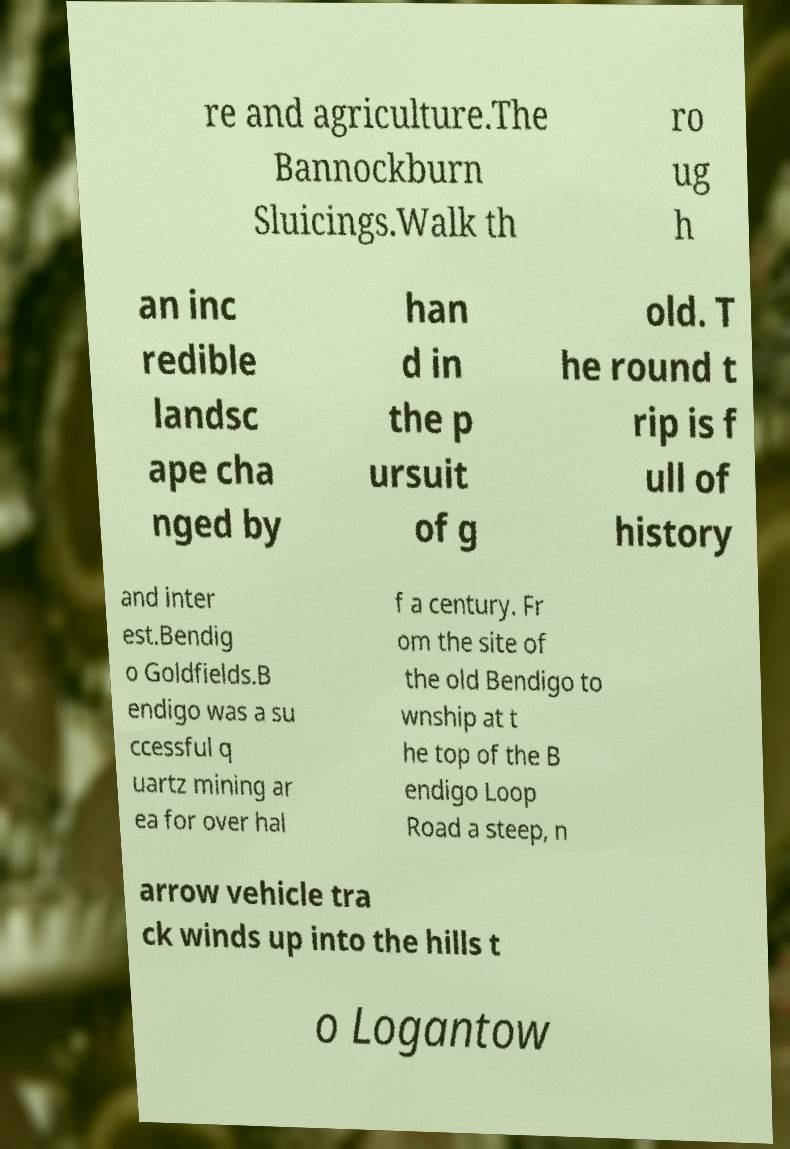What messages or text are displayed in this image? I need them in a readable, typed format. re and agriculture.The Bannockburn Sluicings.Walk th ro ug h an inc redible landsc ape cha nged by han d in the p ursuit of g old. T he round t rip is f ull of history and inter est.Bendig o Goldfields.B endigo was a su ccessful q uartz mining ar ea for over hal f a century. Fr om the site of the old Bendigo to wnship at t he top of the B endigo Loop Road a steep, n arrow vehicle tra ck winds up into the hills t o Logantow 